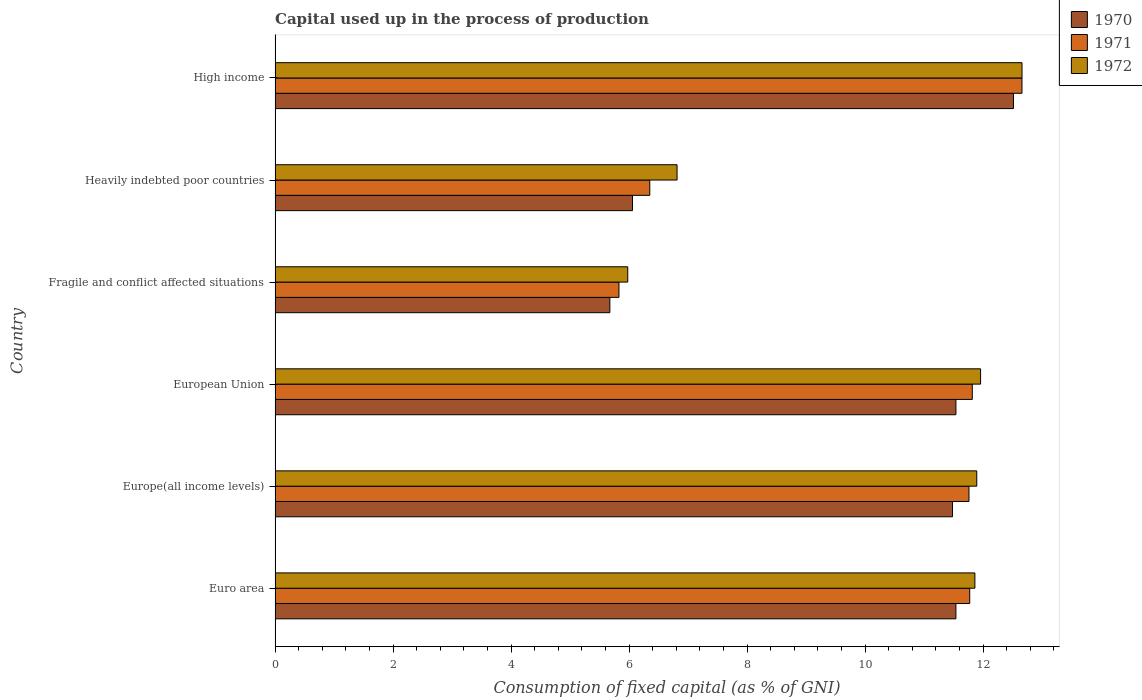How many different coloured bars are there?
Provide a short and direct response. 3. How many groups of bars are there?
Offer a very short reply. 6. Are the number of bars per tick equal to the number of legend labels?
Your response must be concise. Yes. How many bars are there on the 2nd tick from the bottom?
Offer a very short reply. 3. What is the label of the 6th group of bars from the top?
Give a very brief answer. Euro area. In how many cases, is the number of bars for a given country not equal to the number of legend labels?
Ensure brevity in your answer.  0. What is the capital used up in the process of production in 1970 in Euro area?
Keep it short and to the point. 11.54. Across all countries, what is the maximum capital used up in the process of production in 1972?
Make the answer very short. 12.66. Across all countries, what is the minimum capital used up in the process of production in 1972?
Make the answer very short. 5.98. In which country was the capital used up in the process of production in 1972 minimum?
Give a very brief answer. Fragile and conflict affected situations. What is the total capital used up in the process of production in 1970 in the graph?
Make the answer very short. 58.81. What is the difference between the capital used up in the process of production in 1971 in Fragile and conflict affected situations and that in Heavily indebted poor countries?
Ensure brevity in your answer.  -0.52. What is the difference between the capital used up in the process of production in 1970 in Euro area and the capital used up in the process of production in 1971 in Fragile and conflict affected situations?
Offer a terse response. 5.71. What is the average capital used up in the process of production in 1971 per country?
Provide a short and direct response. 10.03. What is the difference between the capital used up in the process of production in 1970 and capital used up in the process of production in 1971 in European Union?
Your answer should be very brief. -0.28. What is the ratio of the capital used up in the process of production in 1971 in Euro area to that in Europe(all income levels)?
Your answer should be very brief. 1. Is the capital used up in the process of production in 1971 in Euro area less than that in Heavily indebted poor countries?
Make the answer very short. No. What is the difference between the highest and the second highest capital used up in the process of production in 1970?
Provide a succinct answer. 0.98. What is the difference between the highest and the lowest capital used up in the process of production in 1971?
Your answer should be very brief. 6.83. Is the sum of the capital used up in the process of production in 1970 in Euro area and Fragile and conflict affected situations greater than the maximum capital used up in the process of production in 1971 across all countries?
Your answer should be compact. Yes. How many countries are there in the graph?
Offer a terse response. 6. What is the difference between two consecutive major ticks on the X-axis?
Offer a very short reply. 2. Does the graph contain any zero values?
Ensure brevity in your answer.  No. What is the title of the graph?
Provide a succinct answer. Capital used up in the process of production. Does "2009" appear as one of the legend labels in the graph?
Offer a very short reply. No. What is the label or title of the X-axis?
Your response must be concise. Consumption of fixed capital (as % of GNI). What is the Consumption of fixed capital (as % of GNI) in 1970 in Euro area?
Your answer should be very brief. 11.54. What is the Consumption of fixed capital (as % of GNI) in 1971 in Euro area?
Your answer should be very brief. 11.77. What is the Consumption of fixed capital (as % of GNI) in 1972 in Euro area?
Offer a terse response. 11.86. What is the Consumption of fixed capital (as % of GNI) of 1970 in Europe(all income levels)?
Your answer should be very brief. 11.48. What is the Consumption of fixed capital (as % of GNI) of 1971 in Europe(all income levels)?
Ensure brevity in your answer.  11.76. What is the Consumption of fixed capital (as % of GNI) in 1972 in Europe(all income levels)?
Keep it short and to the point. 11.89. What is the Consumption of fixed capital (as % of GNI) of 1970 in European Union?
Offer a terse response. 11.54. What is the Consumption of fixed capital (as % of GNI) of 1971 in European Union?
Give a very brief answer. 11.82. What is the Consumption of fixed capital (as % of GNI) in 1972 in European Union?
Provide a succinct answer. 11.96. What is the Consumption of fixed capital (as % of GNI) of 1970 in Fragile and conflict affected situations?
Keep it short and to the point. 5.67. What is the Consumption of fixed capital (as % of GNI) of 1971 in Fragile and conflict affected situations?
Provide a short and direct response. 5.83. What is the Consumption of fixed capital (as % of GNI) in 1972 in Fragile and conflict affected situations?
Provide a short and direct response. 5.98. What is the Consumption of fixed capital (as % of GNI) of 1970 in Heavily indebted poor countries?
Offer a terse response. 6.06. What is the Consumption of fixed capital (as % of GNI) in 1971 in Heavily indebted poor countries?
Give a very brief answer. 6.35. What is the Consumption of fixed capital (as % of GNI) of 1972 in Heavily indebted poor countries?
Your response must be concise. 6.81. What is the Consumption of fixed capital (as % of GNI) of 1970 in High income?
Your response must be concise. 12.52. What is the Consumption of fixed capital (as % of GNI) of 1971 in High income?
Give a very brief answer. 12.66. What is the Consumption of fixed capital (as % of GNI) in 1972 in High income?
Ensure brevity in your answer.  12.66. Across all countries, what is the maximum Consumption of fixed capital (as % of GNI) in 1970?
Keep it short and to the point. 12.52. Across all countries, what is the maximum Consumption of fixed capital (as % of GNI) of 1971?
Your answer should be very brief. 12.66. Across all countries, what is the maximum Consumption of fixed capital (as % of GNI) of 1972?
Your answer should be very brief. 12.66. Across all countries, what is the minimum Consumption of fixed capital (as % of GNI) of 1970?
Provide a succinct answer. 5.67. Across all countries, what is the minimum Consumption of fixed capital (as % of GNI) of 1971?
Provide a short and direct response. 5.83. Across all countries, what is the minimum Consumption of fixed capital (as % of GNI) in 1972?
Your answer should be compact. 5.98. What is the total Consumption of fixed capital (as % of GNI) of 1970 in the graph?
Give a very brief answer. 58.81. What is the total Consumption of fixed capital (as % of GNI) of 1971 in the graph?
Provide a succinct answer. 60.19. What is the total Consumption of fixed capital (as % of GNI) of 1972 in the graph?
Make the answer very short. 61.17. What is the difference between the Consumption of fixed capital (as % of GNI) of 1970 in Euro area and that in Europe(all income levels)?
Your answer should be compact. 0.06. What is the difference between the Consumption of fixed capital (as % of GNI) of 1971 in Euro area and that in Europe(all income levels)?
Provide a succinct answer. 0.01. What is the difference between the Consumption of fixed capital (as % of GNI) in 1972 in Euro area and that in Europe(all income levels)?
Give a very brief answer. -0.03. What is the difference between the Consumption of fixed capital (as % of GNI) of 1970 in Euro area and that in European Union?
Keep it short and to the point. -0. What is the difference between the Consumption of fixed capital (as % of GNI) in 1971 in Euro area and that in European Union?
Provide a short and direct response. -0.04. What is the difference between the Consumption of fixed capital (as % of GNI) of 1972 in Euro area and that in European Union?
Keep it short and to the point. -0.1. What is the difference between the Consumption of fixed capital (as % of GNI) of 1970 in Euro area and that in Fragile and conflict affected situations?
Give a very brief answer. 5.87. What is the difference between the Consumption of fixed capital (as % of GNI) of 1971 in Euro area and that in Fragile and conflict affected situations?
Provide a succinct answer. 5.95. What is the difference between the Consumption of fixed capital (as % of GNI) in 1972 in Euro area and that in Fragile and conflict affected situations?
Give a very brief answer. 5.88. What is the difference between the Consumption of fixed capital (as % of GNI) in 1970 in Euro area and that in Heavily indebted poor countries?
Offer a terse response. 5.48. What is the difference between the Consumption of fixed capital (as % of GNI) of 1971 in Euro area and that in Heavily indebted poor countries?
Your answer should be very brief. 5.42. What is the difference between the Consumption of fixed capital (as % of GNI) of 1972 in Euro area and that in Heavily indebted poor countries?
Offer a very short reply. 5.05. What is the difference between the Consumption of fixed capital (as % of GNI) in 1970 in Euro area and that in High income?
Your answer should be very brief. -0.98. What is the difference between the Consumption of fixed capital (as % of GNI) in 1971 in Euro area and that in High income?
Give a very brief answer. -0.89. What is the difference between the Consumption of fixed capital (as % of GNI) in 1972 in Euro area and that in High income?
Keep it short and to the point. -0.8. What is the difference between the Consumption of fixed capital (as % of GNI) of 1970 in Europe(all income levels) and that in European Union?
Provide a succinct answer. -0.06. What is the difference between the Consumption of fixed capital (as % of GNI) of 1971 in Europe(all income levels) and that in European Union?
Your answer should be very brief. -0.06. What is the difference between the Consumption of fixed capital (as % of GNI) of 1972 in Europe(all income levels) and that in European Union?
Give a very brief answer. -0.06. What is the difference between the Consumption of fixed capital (as % of GNI) of 1970 in Europe(all income levels) and that in Fragile and conflict affected situations?
Your response must be concise. 5.81. What is the difference between the Consumption of fixed capital (as % of GNI) of 1971 in Europe(all income levels) and that in Fragile and conflict affected situations?
Provide a succinct answer. 5.93. What is the difference between the Consumption of fixed capital (as % of GNI) of 1972 in Europe(all income levels) and that in Fragile and conflict affected situations?
Give a very brief answer. 5.92. What is the difference between the Consumption of fixed capital (as % of GNI) of 1970 in Europe(all income levels) and that in Heavily indebted poor countries?
Give a very brief answer. 5.42. What is the difference between the Consumption of fixed capital (as % of GNI) in 1971 in Europe(all income levels) and that in Heavily indebted poor countries?
Your answer should be compact. 5.41. What is the difference between the Consumption of fixed capital (as % of GNI) of 1972 in Europe(all income levels) and that in Heavily indebted poor countries?
Ensure brevity in your answer.  5.08. What is the difference between the Consumption of fixed capital (as % of GNI) in 1970 in Europe(all income levels) and that in High income?
Ensure brevity in your answer.  -1.03. What is the difference between the Consumption of fixed capital (as % of GNI) in 1971 in Europe(all income levels) and that in High income?
Ensure brevity in your answer.  -0.9. What is the difference between the Consumption of fixed capital (as % of GNI) of 1972 in Europe(all income levels) and that in High income?
Make the answer very short. -0.77. What is the difference between the Consumption of fixed capital (as % of GNI) of 1970 in European Union and that in Fragile and conflict affected situations?
Give a very brief answer. 5.87. What is the difference between the Consumption of fixed capital (as % of GNI) of 1971 in European Union and that in Fragile and conflict affected situations?
Provide a short and direct response. 5.99. What is the difference between the Consumption of fixed capital (as % of GNI) in 1972 in European Union and that in Fragile and conflict affected situations?
Provide a succinct answer. 5.98. What is the difference between the Consumption of fixed capital (as % of GNI) of 1970 in European Union and that in Heavily indebted poor countries?
Your answer should be very brief. 5.48. What is the difference between the Consumption of fixed capital (as % of GNI) of 1971 in European Union and that in Heavily indebted poor countries?
Ensure brevity in your answer.  5.47. What is the difference between the Consumption of fixed capital (as % of GNI) in 1972 in European Union and that in Heavily indebted poor countries?
Give a very brief answer. 5.14. What is the difference between the Consumption of fixed capital (as % of GNI) of 1970 in European Union and that in High income?
Ensure brevity in your answer.  -0.98. What is the difference between the Consumption of fixed capital (as % of GNI) in 1971 in European Union and that in High income?
Ensure brevity in your answer.  -0.84. What is the difference between the Consumption of fixed capital (as % of GNI) of 1972 in European Union and that in High income?
Make the answer very short. -0.7. What is the difference between the Consumption of fixed capital (as % of GNI) of 1970 in Fragile and conflict affected situations and that in Heavily indebted poor countries?
Ensure brevity in your answer.  -0.38. What is the difference between the Consumption of fixed capital (as % of GNI) in 1971 in Fragile and conflict affected situations and that in Heavily indebted poor countries?
Your response must be concise. -0.52. What is the difference between the Consumption of fixed capital (as % of GNI) in 1972 in Fragile and conflict affected situations and that in Heavily indebted poor countries?
Provide a succinct answer. -0.84. What is the difference between the Consumption of fixed capital (as % of GNI) of 1970 in Fragile and conflict affected situations and that in High income?
Offer a terse response. -6.84. What is the difference between the Consumption of fixed capital (as % of GNI) of 1971 in Fragile and conflict affected situations and that in High income?
Provide a short and direct response. -6.83. What is the difference between the Consumption of fixed capital (as % of GNI) of 1972 in Fragile and conflict affected situations and that in High income?
Your answer should be very brief. -6.68. What is the difference between the Consumption of fixed capital (as % of GNI) of 1970 in Heavily indebted poor countries and that in High income?
Offer a terse response. -6.46. What is the difference between the Consumption of fixed capital (as % of GNI) in 1971 in Heavily indebted poor countries and that in High income?
Provide a succinct answer. -6.31. What is the difference between the Consumption of fixed capital (as % of GNI) of 1972 in Heavily indebted poor countries and that in High income?
Your response must be concise. -5.85. What is the difference between the Consumption of fixed capital (as % of GNI) of 1970 in Euro area and the Consumption of fixed capital (as % of GNI) of 1971 in Europe(all income levels)?
Ensure brevity in your answer.  -0.22. What is the difference between the Consumption of fixed capital (as % of GNI) in 1970 in Euro area and the Consumption of fixed capital (as % of GNI) in 1972 in Europe(all income levels)?
Ensure brevity in your answer.  -0.35. What is the difference between the Consumption of fixed capital (as % of GNI) of 1971 in Euro area and the Consumption of fixed capital (as % of GNI) of 1972 in Europe(all income levels)?
Keep it short and to the point. -0.12. What is the difference between the Consumption of fixed capital (as % of GNI) of 1970 in Euro area and the Consumption of fixed capital (as % of GNI) of 1971 in European Union?
Your response must be concise. -0.28. What is the difference between the Consumption of fixed capital (as % of GNI) in 1970 in Euro area and the Consumption of fixed capital (as % of GNI) in 1972 in European Union?
Offer a very short reply. -0.42. What is the difference between the Consumption of fixed capital (as % of GNI) of 1971 in Euro area and the Consumption of fixed capital (as % of GNI) of 1972 in European Union?
Give a very brief answer. -0.18. What is the difference between the Consumption of fixed capital (as % of GNI) in 1970 in Euro area and the Consumption of fixed capital (as % of GNI) in 1971 in Fragile and conflict affected situations?
Provide a short and direct response. 5.71. What is the difference between the Consumption of fixed capital (as % of GNI) in 1970 in Euro area and the Consumption of fixed capital (as % of GNI) in 1972 in Fragile and conflict affected situations?
Provide a succinct answer. 5.56. What is the difference between the Consumption of fixed capital (as % of GNI) in 1971 in Euro area and the Consumption of fixed capital (as % of GNI) in 1972 in Fragile and conflict affected situations?
Your answer should be compact. 5.8. What is the difference between the Consumption of fixed capital (as % of GNI) of 1970 in Euro area and the Consumption of fixed capital (as % of GNI) of 1971 in Heavily indebted poor countries?
Ensure brevity in your answer.  5.19. What is the difference between the Consumption of fixed capital (as % of GNI) in 1970 in Euro area and the Consumption of fixed capital (as % of GNI) in 1972 in Heavily indebted poor countries?
Provide a short and direct response. 4.73. What is the difference between the Consumption of fixed capital (as % of GNI) in 1971 in Euro area and the Consumption of fixed capital (as % of GNI) in 1972 in Heavily indebted poor countries?
Offer a very short reply. 4.96. What is the difference between the Consumption of fixed capital (as % of GNI) in 1970 in Euro area and the Consumption of fixed capital (as % of GNI) in 1971 in High income?
Make the answer very short. -1.12. What is the difference between the Consumption of fixed capital (as % of GNI) of 1970 in Euro area and the Consumption of fixed capital (as % of GNI) of 1972 in High income?
Ensure brevity in your answer.  -1.12. What is the difference between the Consumption of fixed capital (as % of GNI) of 1971 in Euro area and the Consumption of fixed capital (as % of GNI) of 1972 in High income?
Offer a very short reply. -0.89. What is the difference between the Consumption of fixed capital (as % of GNI) of 1970 in Europe(all income levels) and the Consumption of fixed capital (as % of GNI) of 1971 in European Union?
Provide a short and direct response. -0.33. What is the difference between the Consumption of fixed capital (as % of GNI) of 1970 in Europe(all income levels) and the Consumption of fixed capital (as % of GNI) of 1972 in European Union?
Provide a short and direct response. -0.48. What is the difference between the Consumption of fixed capital (as % of GNI) in 1971 in Europe(all income levels) and the Consumption of fixed capital (as % of GNI) in 1972 in European Union?
Make the answer very short. -0.2. What is the difference between the Consumption of fixed capital (as % of GNI) in 1970 in Europe(all income levels) and the Consumption of fixed capital (as % of GNI) in 1971 in Fragile and conflict affected situations?
Keep it short and to the point. 5.65. What is the difference between the Consumption of fixed capital (as % of GNI) of 1970 in Europe(all income levels) and the Consumption of fixed capital (as % of GNI) of 1972 in Fragile and conflict affected situations?
Make the answer very short. 5.5. What is the difference between the Consumption of fixed capital (as % of GNI) in 1971 in Europe(all income levels) and the Consumption of fixed capital (as % of GNI) in 1972 in Fragile and conflict affected situations?
Make the answer very short. 5.78. What is the difference between the Consumption of fixed capital (as % of GNI) in 1970 in Europe(all income levels) and the Consumption of fixed capital (as % of GNI) in 1971 in Heavily indebted poor countries?
Your answer should be very brief. 5.13. What is the difference between the Consumption of fixed capital (as % of GNI) of 1970 in Europe(all income levels) and the Consumption of fixed capital (as % of GNI) of 1972 in Heavily indebted poor countries?
Keep it short and to the point. 4.67. What is the difference between the Consumption of fixed capital (as % of GNI) of 1971 in Europe(all income levels) and the Consumption of fixed capital (as % of GNI) of 1972 in Heavily indebted poor countries?
Provide a short and direct response. 4.95. What is the difference between the Consumption of fixed capital (as % of GNI) in 1970 in Europe(all income levels) and the Consumption of fixed capital (as % of GNI) in 1971 in High income?
Your answer should be compact. -1.18. What is the difference between the Consumption of fixed capital (as % of GNI) in 1970 in Europe(all income levels) and the Consumption of fixed capital (as % of GNI) in 1972 in High income?
Offer a terse response. -1.18. What is the difference between the Consumption of fixed capital (as % of GNI) of 1971 in Europe(all income levels) and the Consumption of fixed capital (as % of GNI) of 1972 in High income?
Your answer should be compact. -0.9. What is the difference between the Consumption of fixed capital (as % of GNI) of 1970 in European Union and the Consumption of fixed capital (as % of GNI) of 1971 in Fragile and conflict affected situations?
Keep it short and to the point. 5.71. What is the difference between the Consumption of fixed capital (as % of GNI) in 1970 in European Union and the Consumption of fixed capital (as % of GNI) in 1972 in Fragile and conflict affected situations?
Make the answer very short. 5.56. What is the difference between the Consumption of fixed capital (as % of GNI) in 1971 in European Union and the Consumption of fixed capital (as % of GNI) in 1972 in Fragile and conflict affected situations?
Give a very brief answer. 5.84. What is the difference between the Consumption of fixed capital (as % of GNI) in 1970 in European Union and the Consumption of fixed capital (as % of GNI) in 1971 in Heavily indebted poor countries?
Your response must be concise. 5.19. What is the difference between the Consumption of fixed capital (as % of GNI) in 1970 in European Union and the Consumption of fixed capital (as % of GNI) in 1972 in Heavily indebted poor countries?
Give a very brief answer. 4.73. What is the difference between the Consumption of fixed capital (as % of GNI) in 1971 in European Union and the Consumption of fixed capital (as % of GNI) in 1972 in Heavily indebted poor countries?
Offer a terse response. 5. What is the difference between the Consumption of fixed capital (as % of GNI) in 1970 in European Union and the Consumption of fixed capital (as % of GNI) in 1971 in High income?
Offer a terse response. -1.12. What is the difference between the Consumption of fixed capital (as % of GNI) of 1970 in European Union and the Consumption of fixed capital (as % of GNI) of 1972 in High income?
Provide a short and direct response. -1.12. What is the difference between the Consumption of fixed capital (as % of GNI) of 1971 in European Union and the Consumption of fixed capital (as % of GNI) of 1972 in High income?
Offer a terse response. -0.84. What is the difference between the Consumption of fixed capital (as % of GNI) of 1970 in Fragile and conflict affected situations and the Consumption of fixed capital (as % of GNI) of 1971 in Heavily indebted poor countries?
Your answer should be very brief. -0.68. What is the difference between the Consumption of fixed capital (as % of GNI) in 1970 in Fragile and conflict affected situations and the Consumption of fixed capital (as % of GNI) in 1972 in Heavily indebted poor countries?
Provide a short and direct response. -1.14. What is the difference between the Consumption of fixed capital (as % of GNI) in 1971 in Fragile and conflict affected situations and the Consumption of fixed capital (as % of GNI) in 1972 in Heavily indebted poor countries?
Make the answer very short. -0.99. What is the difference between the Consumption of fixed capital (as % of GNI) of 1970 in Fragile and conflict affected situations and the Consumption of fixed capital (as % of GNI) of 1971 in High income?
Your answer should be compact. -6.99. What is the difference between the Consumption of fixed capital (as % of GNI) of 1970 in Fragile and conflict affected situations and the Consumption of fixed capital (as % of GNI) of 1972 in High income?
Make the answer very short. -6.99. What is the difference between the Consumption of fixed capital (as % of GNI) in 1971 in Fragile and conflict affected situations and the Consumption of fixed capital (as % of GNI) in 1972 in High income?
Keep it short and to the point. -6.83. What is the difference between the Consumption of fixed capital (as % of GNI) in 1970 in Heavily indebted poor countries and the Consumption of fixed capital (as % of GNI) in 1971 in High income?
Provide a succinct answer. -6.6. What is the difference between the Consumption of fixed capital (as % of GNI) of 1970 in Heavily indebted poor countries and the Consumption of fixed capital (as % of GNI) of 1972 in High income?
Offer a very short reply. -6.6. What is the difference between the Consumption of fixed capital (as % of GNI) in 1971 in Heavily indebted poor countries and the Consumption of fixed capital (as % of GNI) in 1972 in High income?
Provide a succinct answer. -6.31. What is the average Consumption of fixed capital (as % of GNI) of 1970 per country?
Provide a succinct answer. 9.8. What is the average Consumption of fixed capital (as % of GNI) of 1971 per country?
Your answer should be compact. 10.03. What is the average Consumption of fixed capital (as % of GNI) of 1972 per country?
Provide a succinct answer. 10.19. What is the difference between the Consumption of fixed capital (as % of GNI) of 1970 and Consumption of fixed capital (as % of GNI) of 1971 in Euro area?
Make the answer very short. -0.23. What is the difference between the Consumption of fixed capital (as % of GNI) in 1970 and Consumption of fixed capital (as % of GNI) in 1972 in Euro area?
Offer a very short reply. -0.32. What is the difference between the Consumption of fixed capital (as % of GNI) of 1971 and Consumption of fixed capital (as % of GNI) of 1972 in Euro area?
Give a very brief answer. -0.09. What is the difference between the Consumption of fixed capital (as % of GNI) in 1970 and Consumption of fixed capital (as % of GNI) in 1971 in Europe(all income levels)?
Keep it short and to the point. -0.28. What is the difference between the Consumption of fixed capital (as % of GNI) of 1970 and Consumption of fixed capital (as % of GNI) of 1972 in Europe(all income levels)?
Give a very brief answer. -0.41. What is the difference between the Consumption of fixed capital (as % of GNI) of 1971 and Consumption of fixed capital (as % of GNI) of 1972 in Europe(all income levels)?
Ensure brevity in your answer.  -0.13. What is the difference between the Consumption of fixed capital (as % of GNI) in 1970 and Consumption of fixed capital (as % of GNI) in 1971 in European Union?
Your response must be concise. -0.28. What is the difference between the Consumption of fixed capital (as % of GNI) of 1970 and Consumption of fixed capital (as % of GNI) of 1972 in European Union?
Offer a terse response. -0.42. What is the difference between the Consumption of fixed capital (as % of GNI) in 1971 and Consumption of fixed capital (as % of GNI) in 1972 in European Union?
Your answer should be compact. -0.14. What is the difference between the Consumption of fixed capital (as % of GNI) of 1970 and Consumption of fixed capital (as % of GNI) of 1971 in Fragile and conflict affected situations?
Provide a short and direct response. -0.15. What is the difference between the Consumption of fixed capital (as % of GNI) in 1970 and Consumption of fixed capital (as % of GNI) in 1972 in Fragile and conflict affected situations?
Offer a terse response. -0.3. What is the difference between the Consumption of fixed capital (as % of GNI) of 1971 and Consumption of fixed capital (as % of GNI) of 1972 in Fragile and conflict affected situations?
Make the answer very short. -0.15. What is the difference between the Consumption of fixed capital (as % of GNI) of 1970 and Consumption of fixed capital (as % of GNI) of 1971 in Heavily indebted poor countries?
Offer a terse response. -0.29. What is the difference between the Consumption of fixed capital (as % of GNI) in 1970 and Consumption of fixed capital (as % of GNI) in 1972 in Heavily indebted poor countries?
Offer a very short reply. -0.76. What is the difference between the Consumption of fixed capital (as % of GNI) of 1971 and Consumption of fixed capital (as % of GNI) of 1972 in Heavily indebted poor countries?
Your response must be concise. -0.46. What is the difference between the Consumption of fixed capital (as % of GNI) of 1970 and Consumption of fixed capital (as % of GNI) of 1971 in High income?
Offer a terse response. -0.14. What is the difference between the Consumption of fixed capital (as % of GNI) in 1970 and Consumption of fixed capital (as % of GNI) in 1972 in High income?
Keep it short and to the point. -0.14. What is the difference between the Consumption of fixed capital (as % of GNI) of 1971 and Consumption of fixed capital (as % of GNI) of 1972 in High income?
Keep it short and to the point. -0. What is the ratio of the Consumption of fixed capital (as % of GNI) of 1972 in Euro area to that in Europe(all income levels)?
Ensure brevity in your answer.  1. What is the ratio of the Consumption of fixed capital (as % of GNI) of 1970 in Euro area to that in European Union?
Your answer should be very brief. 1. What is the ratio of the Consumption of fixed capital (as % of GNI) of 1972 in Euro area to that in European Union?
Your answer should be very brief. 0.99. What is the ratio of the Consumption of fixed capital (as % of GNI) of 1970 in Euro area to that in Fragile and conflict affected situations?
Give a very brief answer. 2.03. What is the ratio of the Consumption of fixed capital (as % of GNI) in 1971 in Euro area to that in Fragile and conflict affected situations?
Keep it short and to the point. 2.02. What is the ratio of the Consumption of fixed capital (as % of GNI) of 1972 in Euro area to that in Fragile and conflict affected situations?
Ensure brevity in your answer.  1.98. What is the ratio of the Consumption of fixed capital (as % of GNI) of 1970 in Euro area to that in Heavily indebted poor countries?
Give a very brief answer. 1.9. What is the ratio of the Consumption of fixed capital (as % of GNI) in 1971 in Euro area to that in Heavily indebted poor countries?
Provide a succinct answer. 1.85. What is the ratio of the Consumption of fixed capital (as % of GNI) in 1972 in Euro area to that in Heavily indebted poor countries?
Provide a succinct answer. 1.74. What is the ratio of the Consumption of fixed capital (as % of GNI) in 1970 in Euro area to that in High income?
Provide a short and direct response. 0.92. What is the ratio of the Consumption of fixed capital (as % of GNI) in 1971 in Euro area to that in High income?
Provide a short and direct response. 0.93. What is the ratio of the Consumption of fixed capital (as % of GNI) in 1972 in Euro area to that in High income?
Your answer should be very brief. 0.94. What is the ratio of the Consumption of fixed capital (as % of GNI) of 1970 in Europe(all income levels) to that in Fragile and conflict affected situations?
Ensure brevity in your answer.  2.02. What is the ratio of the Consumption of fixed capital (as % of GNI) in 1971 in Europe(all income levels) to that in Fragile and conflict affected situations?
Provide a succinct answer. 2.02. What is the ratio of the Consumption of fixed capital (as % of GNI) of 1972 in Europe(all income levels) to that in Fragile and conflict affected situations?
Provide a short and direct response. 1.99. What is the ratio of the Consumption of fixed capital (as % of GNI) of 1970 in Europe(all income levels) to that in Heavily indebted poor countries?
Your response must be concise. 1.9. What is the ratio of the Consumption of fixed capital (as % of GNI) of 1971 in Europe(all income levels) to that in Heavily indebted poor countries?
Your response must be concise. 1.85. What is the ratio of the Consumption of fixed capital (as % of GNI) in 1972 in Europe(all income levels) to that in Heavily indebted poor countries?
Provide a succinct answer. 1.75. What is the ratio of the Consumption of fixed capital (as % of GNI) of 1970 in Europe(all income levels) to that in High income?
Your response must be concise. 0.92. What is the ratio of the Consumption of fixed capital (as % of GNI) of 1971 in Europe(all income levels) to that in High income?
Ensure brevity in your answer.  0.93. What is the ratio of the Consumption of fixed capital (as % of GNI) of 1972 in Europe(all income levels) to that in High income?
Ensure brevity in your answer.  0.94. What is the ratio of the Consumption of fixed capital (as % of GNI) of 1970 in European Union to that in Fragile and conflict affected situations?
Keep it short and to the point. 2.03. What is the ratio of the Consumption of fixed capital (as % of GNI) of 1971 in European Union to that in Fragile and conflict affected situations?
Provide a succinct answer. 2.03. What is the ratio of the Consumption of fixed capital (as % of GNI) in 1972 in European Union to that in Fragile and conflict affected situations?
Make the answer very short. 2. What is the ratio of the Consumption of fixed capital (as % of GNI) of 1970 in European Union to that in Heavily indebted poor countries?
Make the answer very short. 1.9. What is the ratio of the Consumption of fixed capital (as % of GNI) of 1971 in European Union to that in Heavily indebted poor countries?
Provide a short and direct response. 1.86. What is the ratio of the Consumption of fixed capital (as % of GNI) of 1972 in European Union to that in Heavily indebted poor countries?
Give a very brief answer. 1.75. What is the ratio of the Consumption of fixed capital (as % of GNI) in 1970 in European Union to that in High income?
Provide a succinct answer. 0.92. What is the ratio of the Consumption of fixed capital (as % of GNI) in 1971 in European Union to that in High income?
Your response must be concise. 0.93. What is the ratio of the Consumption of fixed capital (as % of GNI) of 1972 in European Union to that in High income?
Provide a short and direct response. 0.94. What is the ratio of the Consumption of fixed capital (as % of GNI) in 1970 in Fragile and conflict affected situations to that in Heavily indebted poor countries?
Provide a short and direct response. 0.94. What is the ratio of the Consumption of fixed capital (as % of GNI) of 1971 in Fragile and conflict affected situations to that in Heavily indebted poor countries?
Offer a very short reply. 0.92. What is the ratio of the Consumption of fixed capital (as % of GNI) in 1972 in Fragile and conflict affected situations to that in Heavily indebted poor countries?
Your response must be concise. 0.88. What is the ratio of the Consumption of fixed capital (as % of GNI) of 1970 in Fragile and conflict affected situations to that in High income?
Give a very brief answer. 0.45. What is the ratio of the Consumption of fixed capital (as % of GNI) of 1971 in Fragile and conflict affected situations to that in High income?
Ensure brevity in your answer.  0.46. What is the ratio of the Consumption of fixed capital (as % of GNI) of 1972 in Fragile and conflict affected situations to that in High income?
Your response must be concise. 0.47. What is the ratio of the Consumption of fixed capital (as % of GNI) of 1970 in Heavily indebted poor countries to that in High income?
Make the answer very short. 0.48. What is the ratio of the Consumption of fixed capital (as % of GNI) in 1971 in Heavily indebted poor countries to that in High income?
Give a very brief answer. 0.5. What is the ratio of the Consumption of fixed capital (as % of GNI) of 1972 in Heavily indebted poor countries to that in High income?
Give a very brief answer. 0.54. What is the difference between the highest and the second highest Consumption of fixed capital (as % of GNI) in 1970?
Your response must be concise. 0.98. What is the difference between the highest and the second highest Consumption of fixed capital (as % of GNI) in 1971?
Offer a terse response. 0.84. What is the difference between the highest and the second highest Consumption of fixed capital (as % of GNI) in 1972?
Offer a very short reply. 0.7. What is the difference between the highest and the lowest Consumption of fixed capital (as % of GNI) of 1970?
Your response must be concise. 6.84. What is the difference between the highest and the lowest Consumption of fixed capital (as % of GNI) in 1971?
Your answer should be compact. 6.83. What is the difference between the highest and the lowest Consumption of fixed capital (as % of GNI) in 1972?
Your answer should be compact. 6.68. 